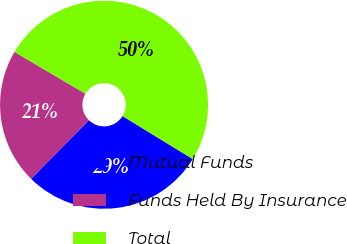Convert chart. <chart><loc_0><loc_0><loc_500><loc_500><pie_chart><fcel>Mutual Funds<fcel>Funds Held By Insurance<fcel>Total<nl><fcel>28.64%<fcel>21.11%<fcel>50.25%<nl></chart> 